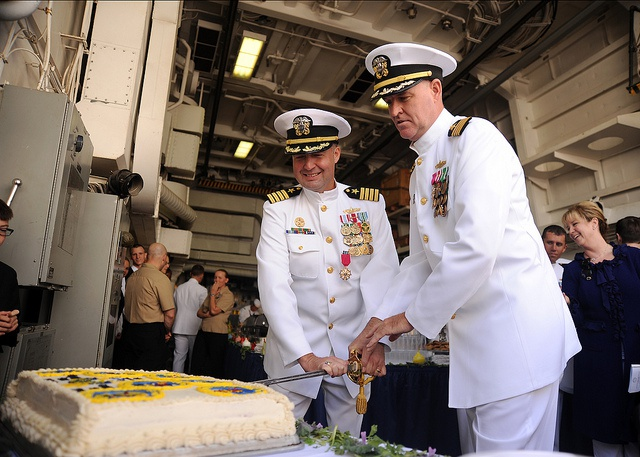Describe the objects in this image and their specific colors. I can see people in black, lavender, and darkgray tones, people in black, lavender, darkgray, and brown tones, cake in black, tan, lightgray, and gray tones, people in black, tan, brown, and navy tones, and people in black, gray, brown, and tan tones in this image. 